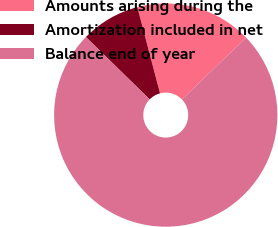<chart> <loc_0><loc_0><loc_500><loc_500><pie_chart><fcel>Amounts arising during the<fcel>Amortization included in net<fcel>Balance end of year<nl><fcel>16.88%<fcel>8.59%<fcel>74.53%<nl></chart> 